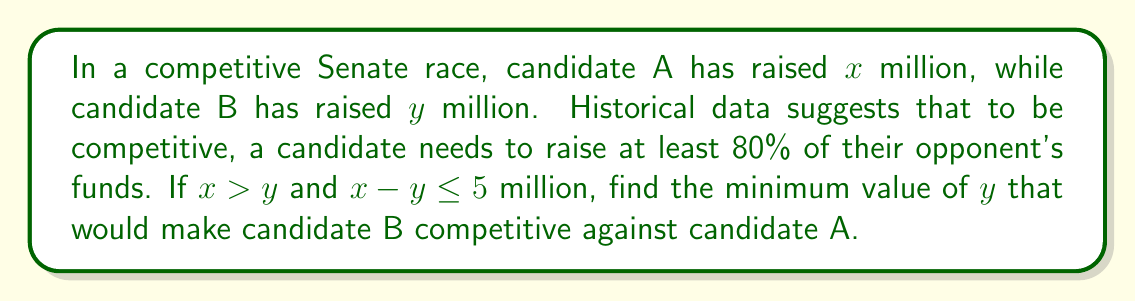What is the answer to this math problem? Let's approach this step-by-step:

1) For candidate B to be competitive, they need to raise at least 80% of candidate A's funds. We can express this as an inequality:

   $y \geq 0.8x$

2) We're also told that $x > y$ and $x - y \leq 5$. Let's use the second condition:

   $x - y \leq 5$
   $x \leq y + 5$

3) Substituting this into our first inequality:

   $y \geq 0.8(y + 5)$

4) Let's solve this inequality:

   $y \geq 0.8y + 4$
   $0.2y \geq 4$
   $y \geq 20$

5) Therefore, the minimum value of $y$ that satisfies all conditions is 20 million dollars.

6) Let's verify that this satisfies all conditions:
   - If $y = 20$, then $x$ could be up to 25 (satisfying $x - y \leq 5$)
   - $20 \geq 0.8(25) = 20$, so it meets the 80% threshold

Thus, candidate B needs to raise at least $20 million to be competitive.
Answer: $20 million 